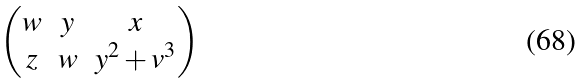<formula> <loc_0><loc_0><loc_500><loc_500>\begin{pmatrix} w & y & x \\ z & w & y ^ { 2 } + v ^ { 3 } \end{pmatrix}</formula> 